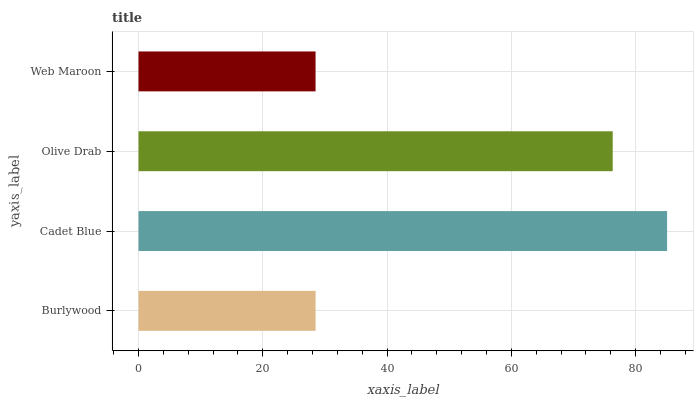Is Web Maroon the minimum?
Answer yes or no. Yes. Is Cadet Blue the maximum?
Answer yes or no. Yes. Is Olive Drab the minimum?
Answer yes or no. No. Is Olive Drab the maximum?
Answer yes or no. No. Is Cadet Blue greater than Olive Drab?
Answer yes or no. Yes. Is Olive Drab less than Cadet Blue?
Answer yes or no. Yes. Is Olive Drab greater than Cadet Blue?
Answer yes or no. No. Is Cadet Blue less than Olive Drab?
Answer yes or no. No. Is Olive Drab the high median?
Answer yes or no. Yes. Is Burlywood the low median?
Answer yes or no. Yes. Is Cadet Blue the high median?
Answer yes or no. No. Is Web Maroon the low median?
Answer yes or no. No. 